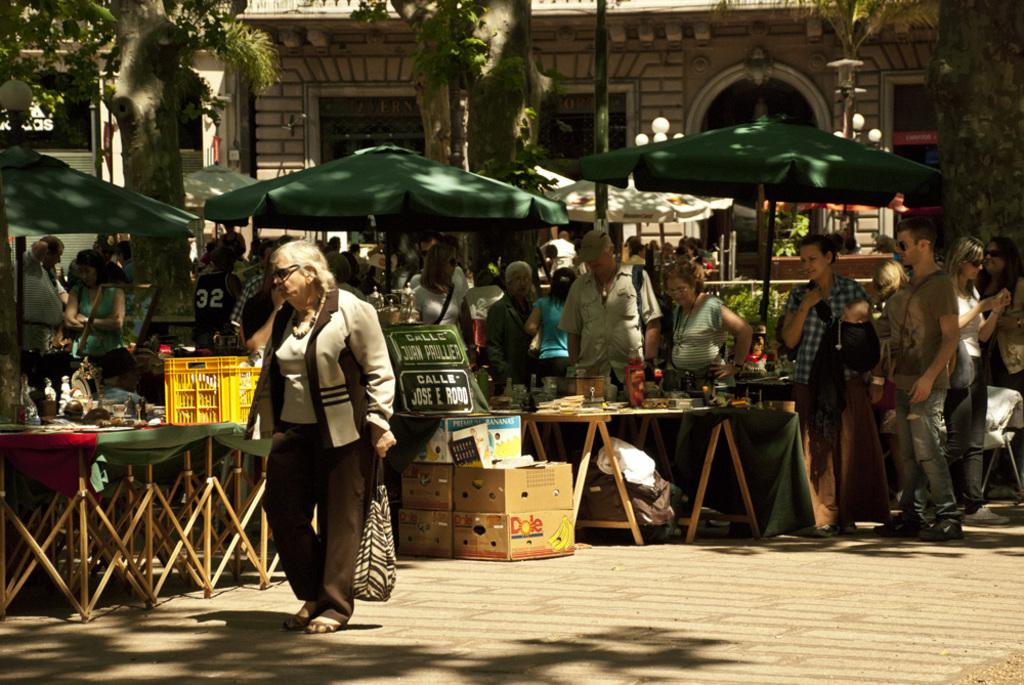What fruit company is on the brown box?
Make the answer very short. Dole. 